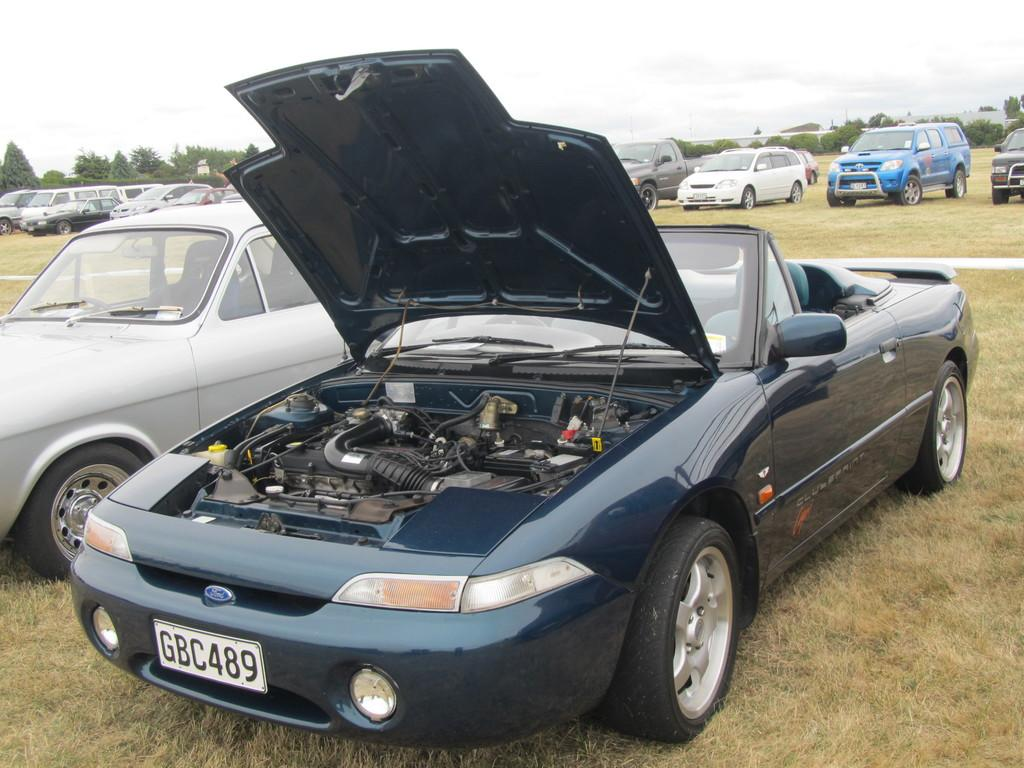What types of objects are on the ground in the image? There are vehicles on the ground in the image. What type of vegetation can be seen in the image? There are trees and grass in the image. What is visible in the background of the image? The sky is visible in the background of the image. What can be seen in the sky in the image? Clouds are present in the sky. What type of dirt can be seen on the vehicles in the image? There is no dirt visible on the vehicles in the image; they appear clean. How does the heat affect the trees in the image? There is no mention of heat in the image, and therefore its effect on the trees cannot be determined. 